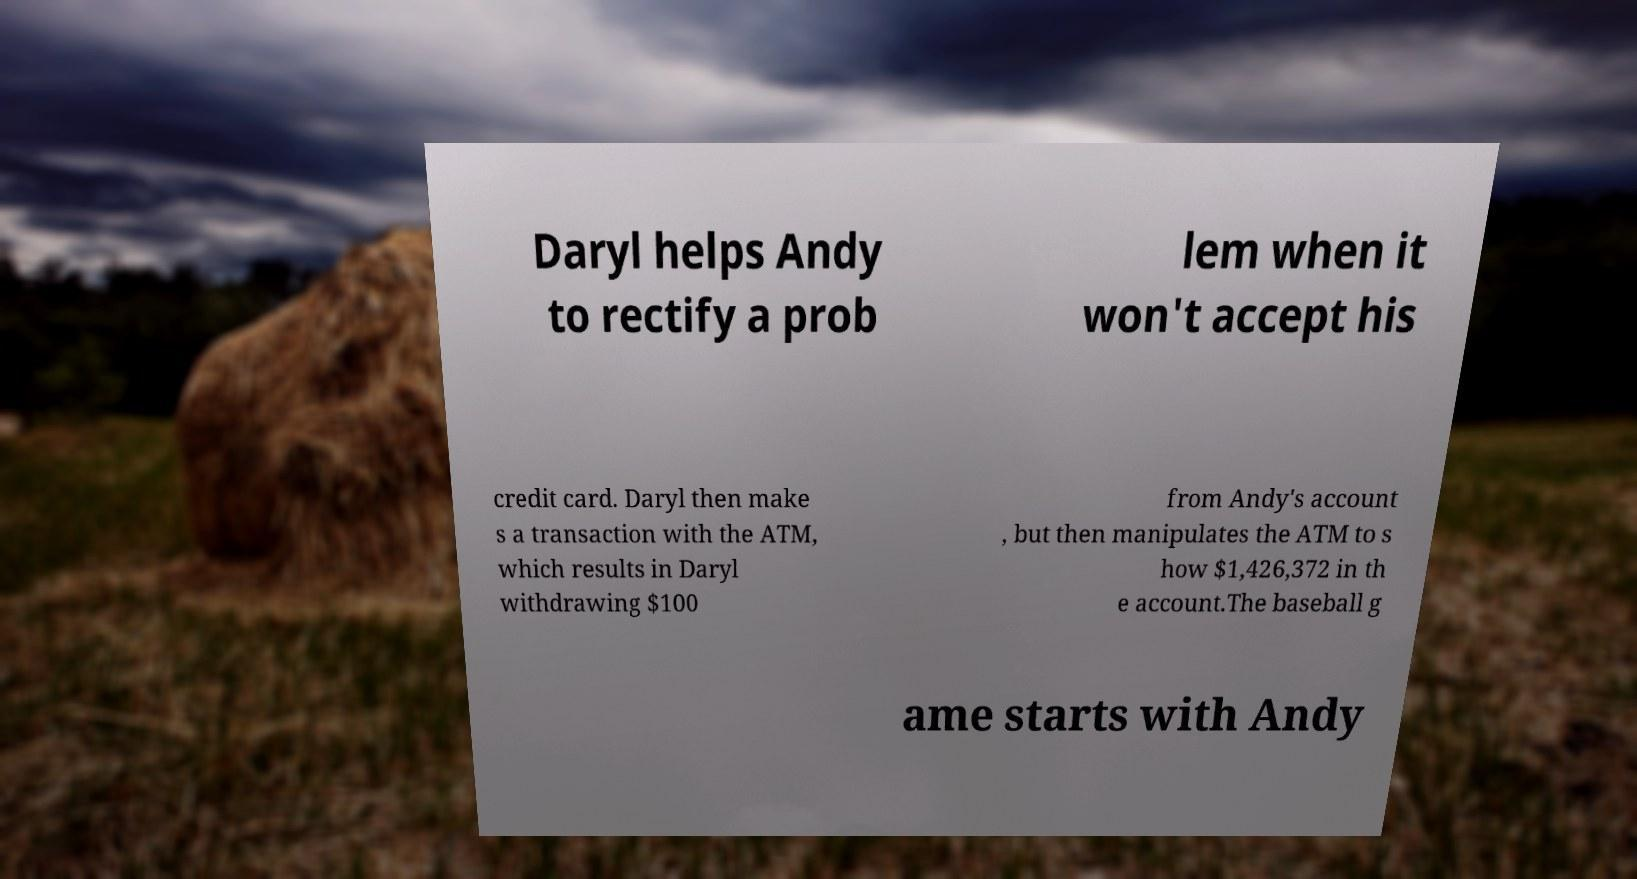Please identify and transcribe the text found in this image. Daryl helps Andy to rectify a prob lem when it won't accept his credit card. Daryl then make s a transaction with the ATM, which results in Daryl withdrawing $100 from Andy's account , but then manipulates the ATM to s how $1,426,372 in th e account.The baseball g ame starts with Andy 